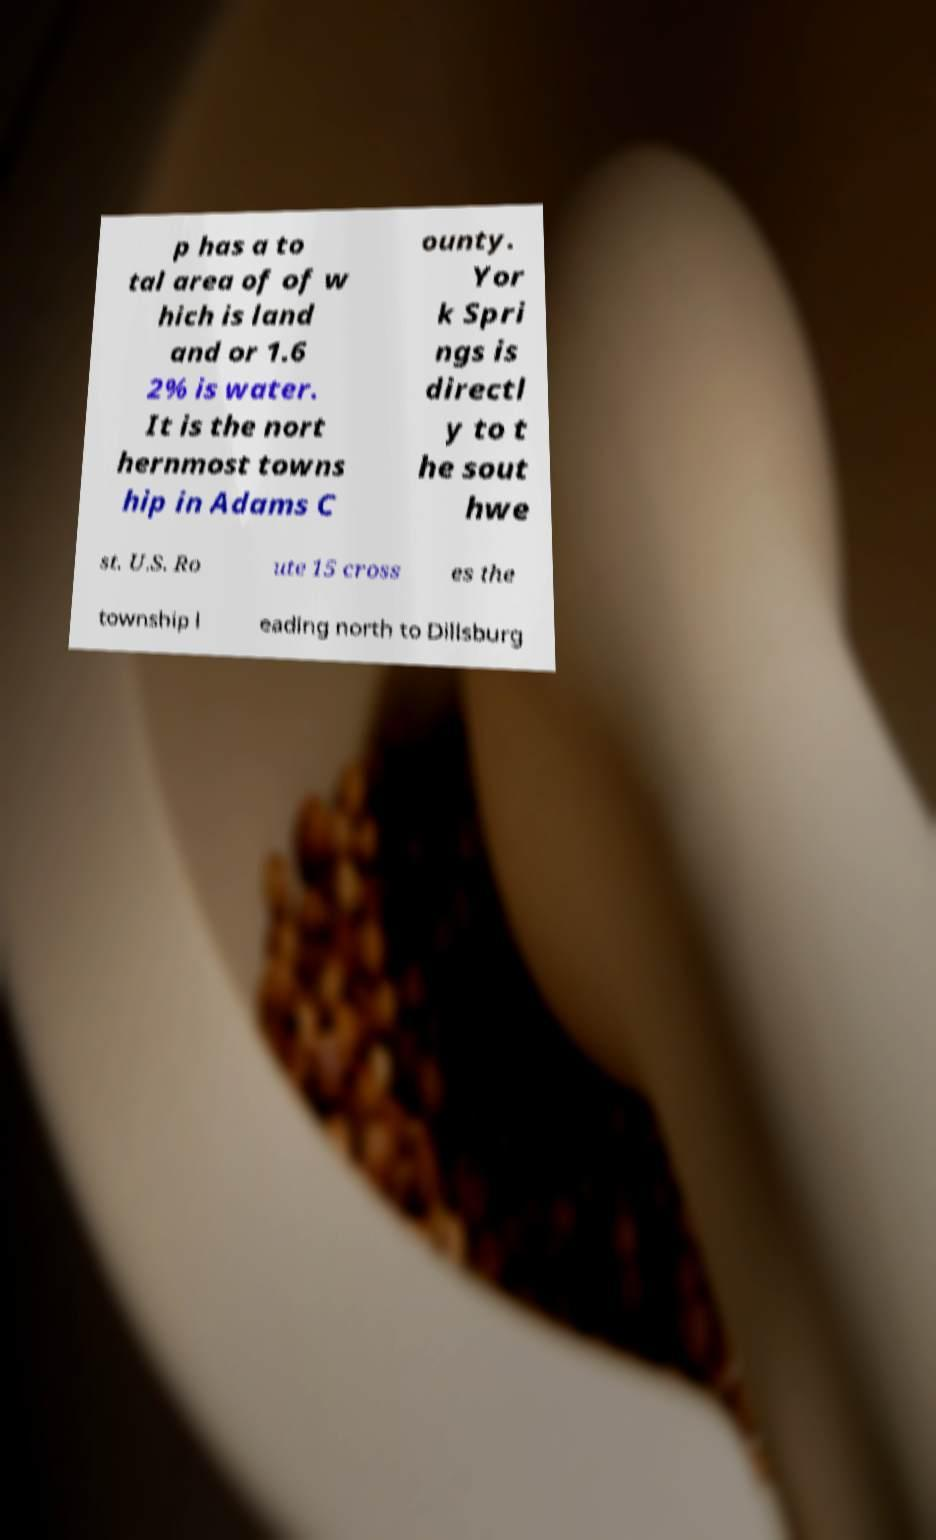What messages or text are displayed in this image? I need them in a readable, typed format. p has a to tal area of of w hich is land and or 1.6 2% is water. It is the nort hernmost towns hip in Adams C ounty. Yor k Spri ngs is directl y to t he sout hwe st. U.S. Ro ute 15 cross es the township l eading north to Dillsburg 